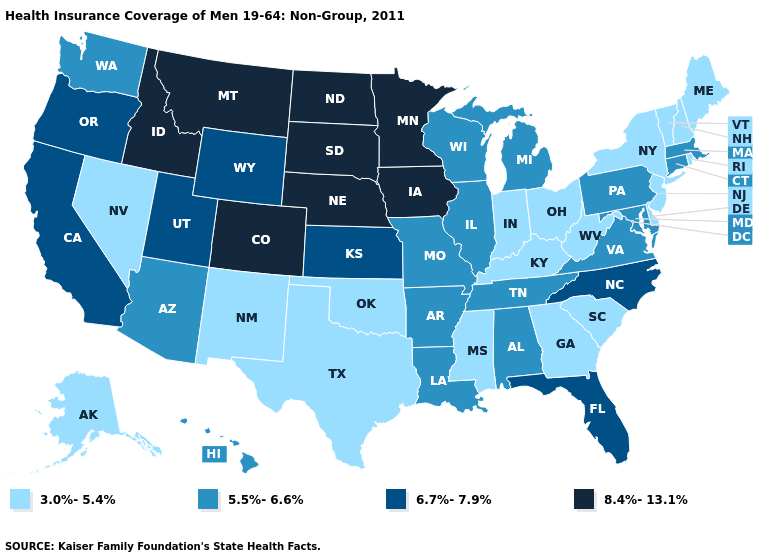Among the states that border North Carolina , which have the lowest value?
Quick response, please. Georgia, South Carolina. Name the states that have a value in the range 8.4%-13.1%?
Be succinct. Colorado, Idaho, Iowa, Minnesota, Montana, Nebraska, North Dakota, South Dakota. Name the states that have a value in the range 5.5%-6.6%?
Keep it brief. Alabama, Arizona, Arkansas, Connecticut, Hawaii, Illinois, Louisiana, Maryland, Massachusetts, Michigan, Missouri, Pennsylvania, Tennessee, Virginia, Washington, Wisconsin. Does Minnesota have the highest value in the USA?
Answer briefly. Yes. What is the value of Maryland?
Quick response, please. 5.5%-6.6%. How many symbols are there in the legend?
Concise answer only. 4. What is the value of Kentucky?
Quick response, please. 3.0%-5.4%. Name the states that have a value in the range 6.7%-7.9%?
Quick response, please. California, Florida, Kansas, North Carolina, Oregon, Utah, Wyoming. Name the states that have a value in the range 6.7%-7.9%?
Short answer required. California, Florida, Kansas, North Carolina, Oregon, Utah, Wyoming. What is the value of Hawaii?
Short answer required. 5.5%-6.6%. Among the states that border Minnesota , does South Dakota have the lowest value?
Concise answer only. No. Name the states that have a value in the range 5.5%-6.6%?
Write a very short answer. Alabama, Arizona, Arkansas, Connecticut, Hawaii, Illinois, Louisiana, Maryland, Massachusetts, Michigan, Missouri, Pennsylvania, Tennessee, Virginia, Washington, Wisconsin. Among the states that border Minnesota , does Wisconsin have the highest value?
Give a very brief answer. No. Does the map have missing data?
Write a very short answer. No. What is the value of Indiana?
Answer briefly. 3.0%-5.4%. 